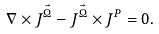<formula> <loc_0><loc_0><loc_500><loc_500>\nabla \times J ^ { \vec { \Omega } } - J ^ { \vec { \Omega } } \times J ^ { P } = 0 .</formula> 